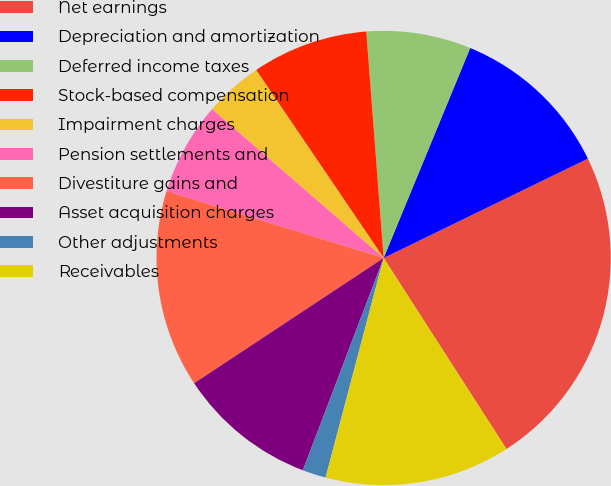Convert chart to OTSL. <chart><loc_0><loc_0><loc_500><loc_500><pie_chart><fcel>Net earnings<fcel>Depreciation and amortization<fcel>Deferred income taxes<fcel>Stock-based compensation<fcel>Impairment charges<fcel>Pension settlements and<fcel>Divestiture gains and<fcel>Asset acquisition charges<fcel>Other adjustments<fcel>Receivables<nl><fcel>23.11%<fcel>11.57%<fcel>7.44%<fcel>8.27%<fcel>4.15%<fcel>6.62%<fcel>14.04%<fcel>9.92%<fcel>1.67%<fcel>13.21%<nl></chart> 